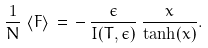<formula> <loc_0><loc_0><loc_500><loc_500>\frac { 1 } { N } \, \left \langle F \right \rangle \, = \, - \, \frac { \epsilon } { I ( T , \epsilon ) } \, \frac { x } { \tanh ( x ) } .</formula> 